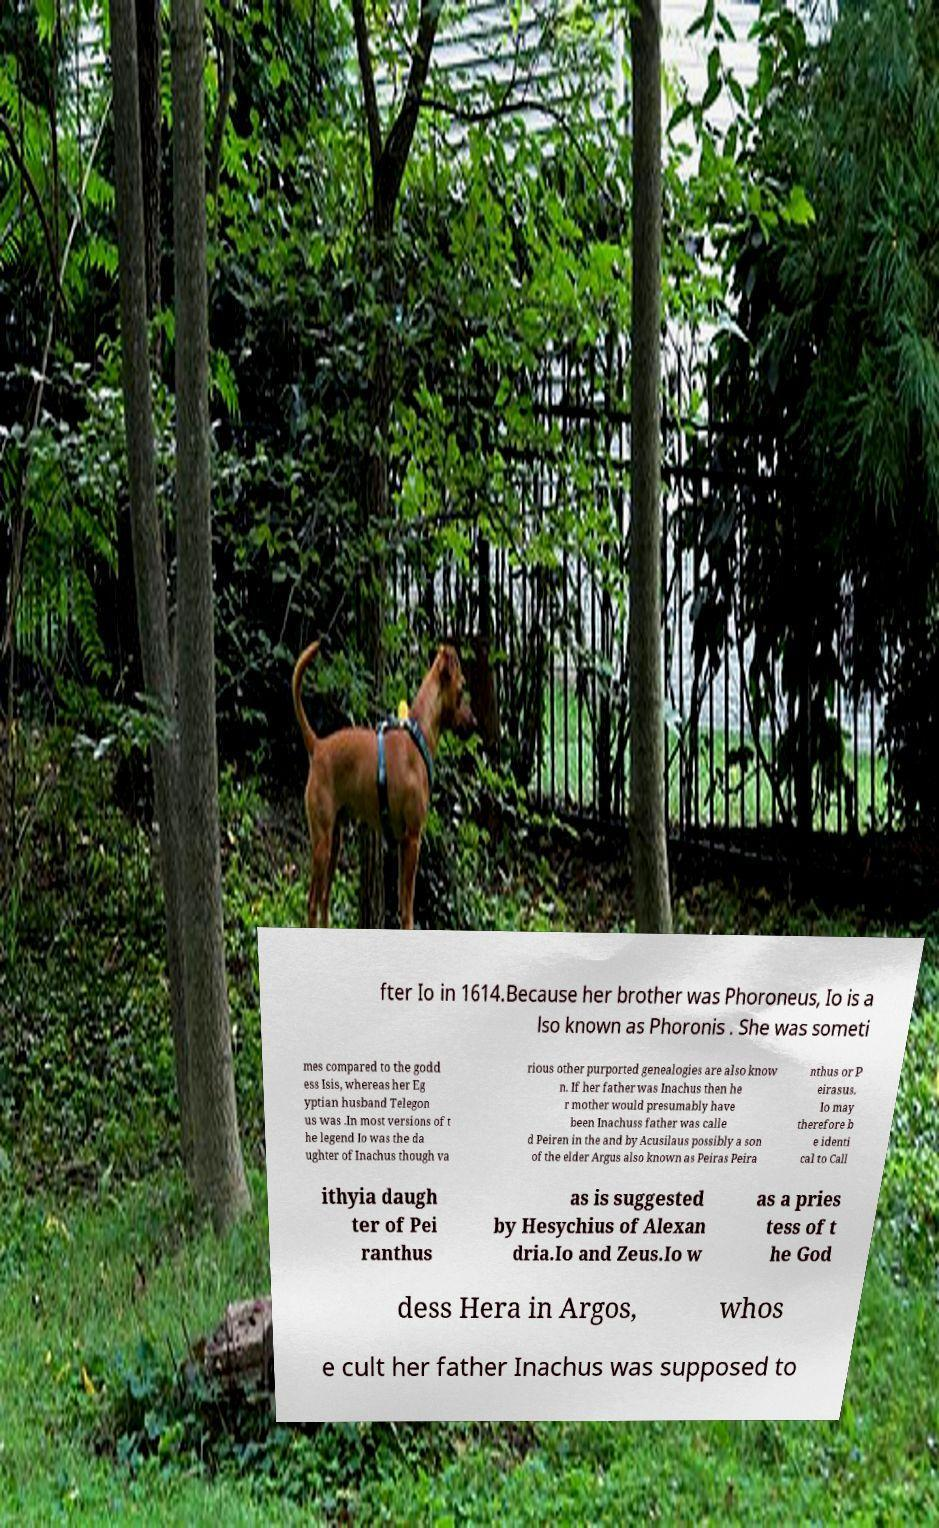I need the written content from this picture converted into text. Can you do that? fter Io in 1614.Because her brother was Phoroneus, Io is a lso known as Phoronis . She was someti mes compared to the godd ess Isis, whereas her Eg yptian husband Telegon us was .In most versions of t he legend Io was the da ughter of Inachus though va rious other purported genealogies are also know n. If her father was Inachus then he r mother would presumably have been Inachuss father was calle d Peiren in the and by Acusilaus possibly a son of the elder Argus also known as Peiras Peira nthus or P eirasus. Io may therefore b e identi cal to Call ithyia daugh ter of Pei ranthus as is suggested by Hesychius of Alexan dria.Io and Zeus.Io w as a pries tess of t he God dess Hera in Argos, whos e cult her father Inachus was supposed to 